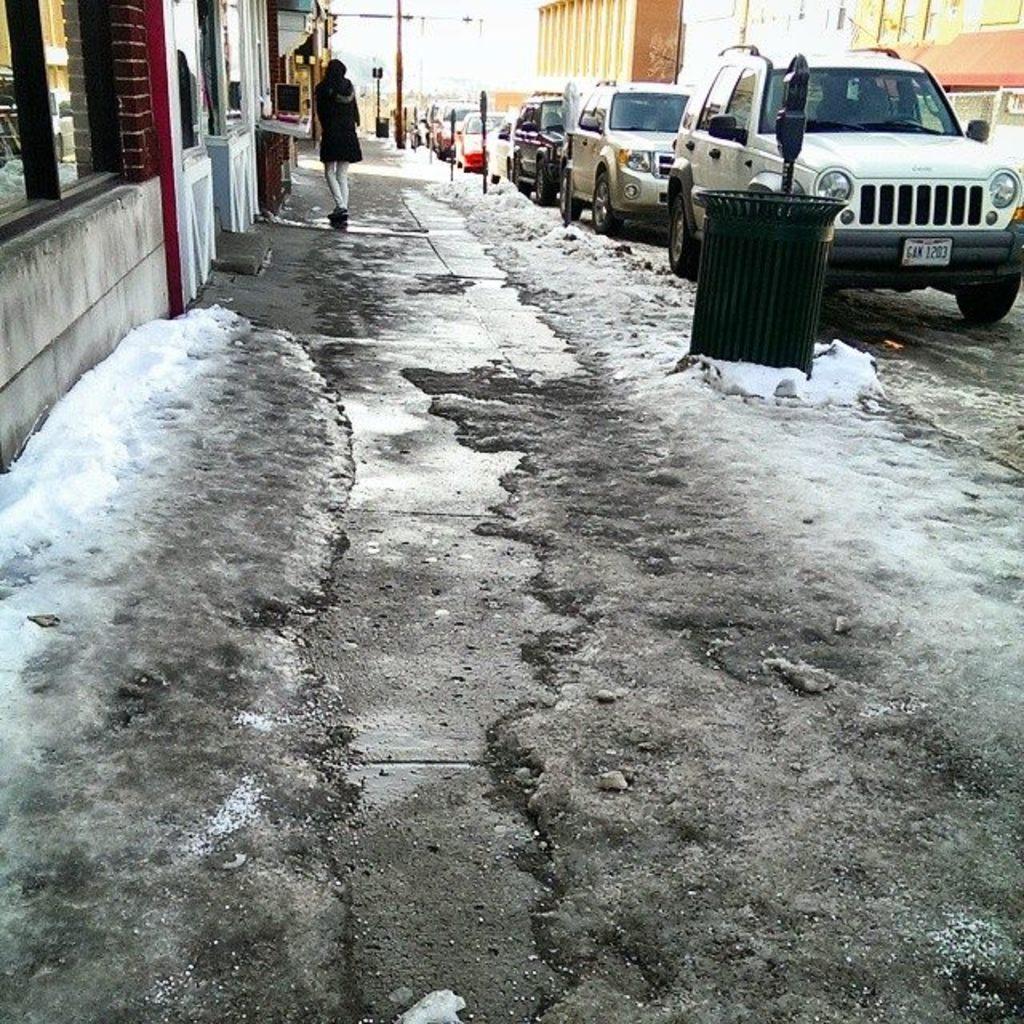Describe this image in one or two sentences. There is ice in the foreground area of the image, there are vehicles, poles, buildings and a person in the background. 